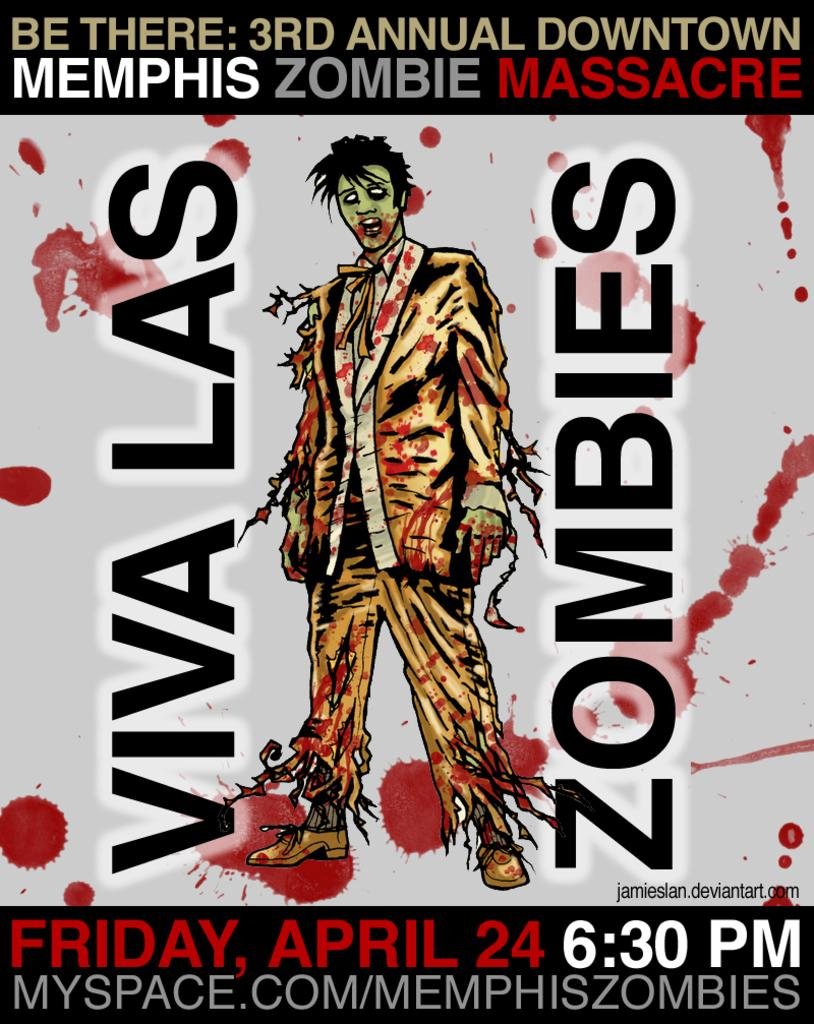What is the main object in the image? There is a poster in the image. What is depicted on the poster? The poster contains a picture of a person. Is there any text on the poster? Yes, there is text written on the poster. What does your dad think about the poster in the image? There is no information about your dad or his opinion in the image, as it only contains a poster with a picture of a person and text. 